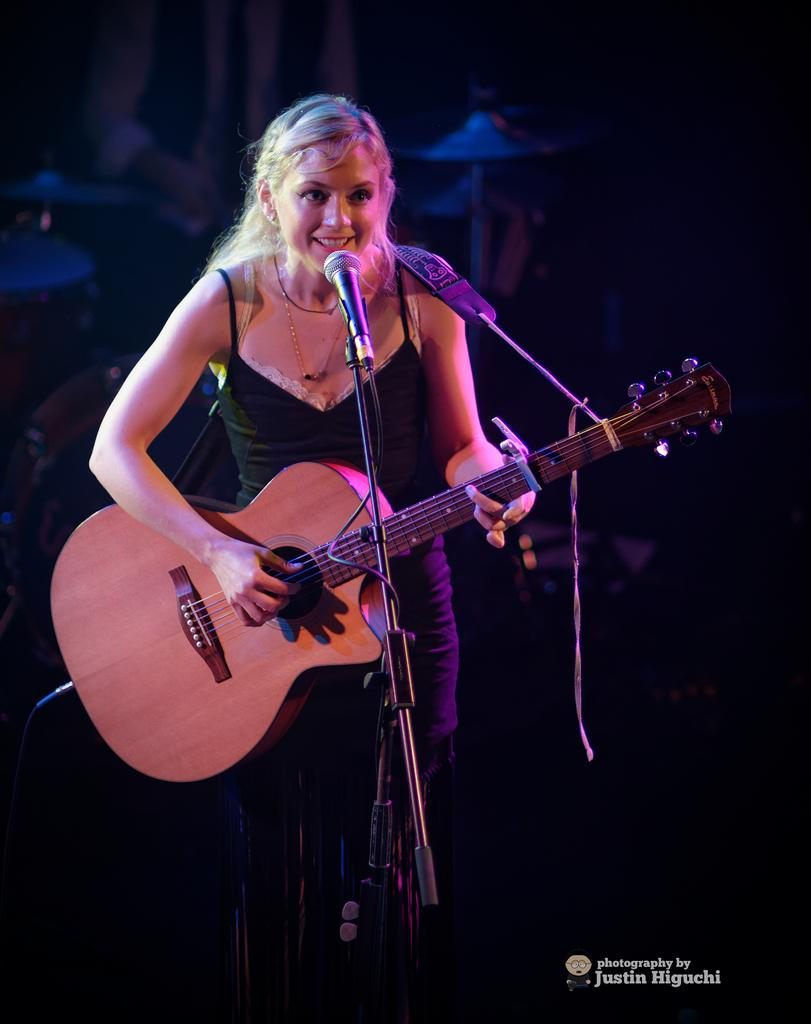What is the person in the foreground of the image doing? The person is standing and smiling in the image. What instrument is the person in the foreground playing? The person is playing a guitar. Can you describe the person in the background of the image? There is a person playing drums in the background. What is the main object in the front of the image? There is a microphone in the front of the image. What type of caption is written on the guitar in the image? There is no caption written on the guitar in the image. How does the heat affect the performance of the musicians in the image? The image does not provide any information about the temperature or heat, so it cannot be determined how it affects the musicians' performance. 